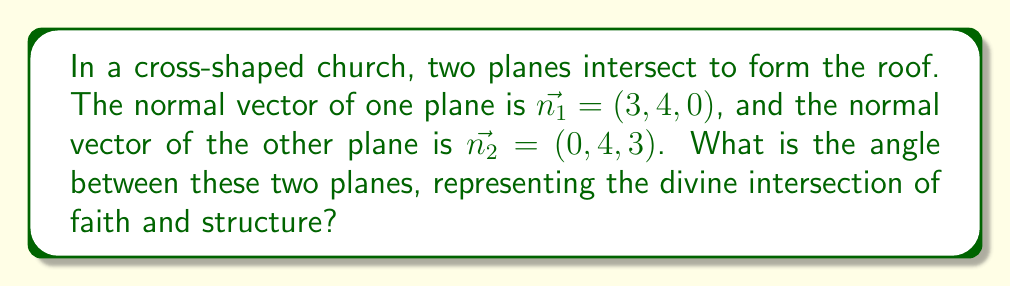Show me your answer to this math problem. To find the angle between two intersecting planes, we can use the following steps:

1) The angle between two planes is the same as the angle between their normal vectors.

2) We can find the angle between two vectors using the dot product formula:

   $$\cos \theta = \frac{\vec{n_1} \cdot \vec{n_2}}{|\vec{n_1}||\vec{n_2}|}$$

3) Calculate the dot product $\vec{n_1} \cdot \vec{n_2}$:
   $$(3, 4, 0) \cdot (0, 4, 3) = 3(0) + 4(4) + 0(3) = 16$$

4) Calculate the magnitudes of the vectors:
   $$|\vec{n_1}| = \sqrt{3^2 + 4^2 + 0^2} = \sqrt{25} = 5$$
   $$|\vec{n_2}| = \sqrt{0^2 + 4^2 + 3^2} = \sqrt{25} = 5$$

5) Substitute into the formula:
   $$\cos \theta = \frac{16}{5 \cdot 5} = \frac{16}{25} = 0.64$$

6) Take the inverse cosine (arccos) of both sides:
   $$\theta = \arccos(0.64) \approx 0.8761 \text{ radians}$$

7) Convert to degrees:
   $$\theta \approx 0.8761 \cdot \frac{180}{\pi} \approx 50.21°$$
Answer: $50.21°$ 